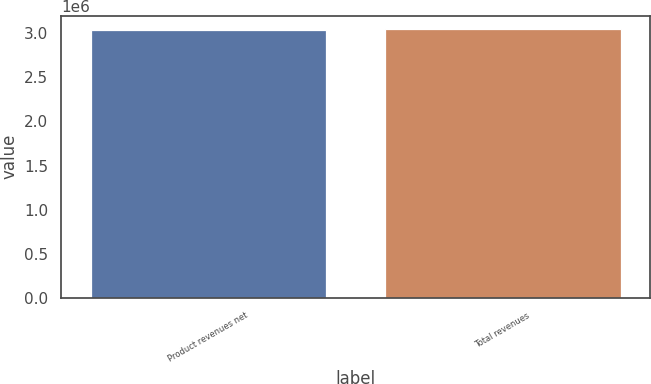Convert chart to OTSL. <chart><loc_0><loc_0><loc_500><loc_500><bar_chart><fcel>Product revenues net<fcel>Total revenues<nl><fcel>3.03832e+06<fcel>3.0476e+06<nl></chart> 